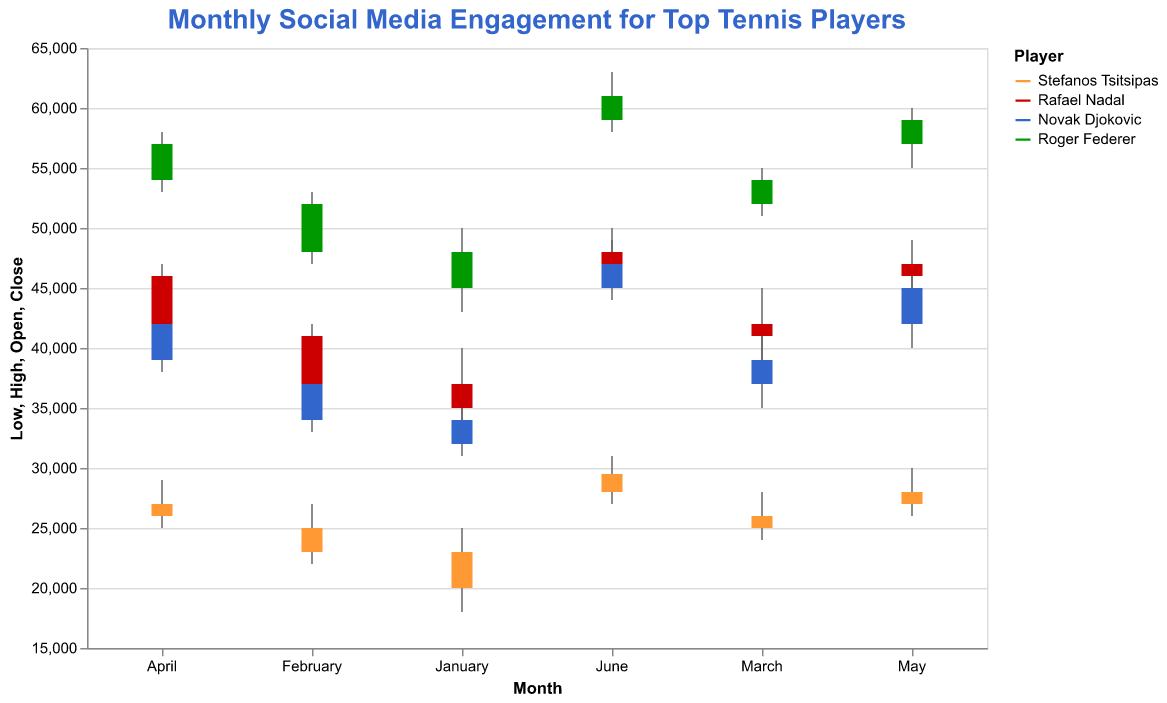What is the highest social media engagement for Stefanos Tsitsipas in February? The highest social media engagement for Stefanos Tsitsipas in February is displayed as the "High" value for that month. According to the data, this value is 27000.
Answer: 27000 How much did Rafael Nadal's social media engagement increase from January to February? To find the increase, subtract Nadal's "Open" engagement in January from his "Close" engagement in February. The values are 37000 (February Close) and 35000 (January Open). The increase is 37000 - 35000 = 2000.
Answer: 2000 Which player had the lowest social media engagement in March? To find this, look at the "Low" values for each player in March. Tsitsipas has 24000, Nadal has 39000, Djokovic has 35000, and Federer has 51000. The lowest value is 24000 for Tsitsipas.
Answer: Stefanos Tsitsipas Compare the social media engagement in June for Stefanos Tsitsipas and Rafael Nadal. Who had higher "Close" engagement? Compare the "Close" values in June for both players. Tsitsipas has 29500 and Nadal has 48000. Nadal's engagement is higher.
Answer: Rafael Nadal What is the range of social media engagement for Novak Djokovic in April? The range is found by subtracting the "Low" value from the "High" value for April. For Djokovic, these values are 38000 (Low) and 43000 (High). The range is 43000 - 38000 = 5000.
Answer: 5000 Which month shows the highest closing engagement for Roger Federer? To find this, examine the "Close" values for Federer across all months. The values are January (48000), February (52000), March (54000), April (57000), May (59000), and June (61000). The highest is 61000 in June.
Answer: June What is the average "Close" engagement for Stefanos Tsitsipas from January to June? To calculate the average "Close" engagement, sum the "Close" values for Tsitsipas from January to June and divide by the number of months. The sum is  (23000 + 25000 + 26000 + 27000 + 28000 + 29500) = 158500. The average is 158500 / 6 ≈ 26417.
Answer: 26417 How does the "Open" engagement for Rafael Nadal in May compare to the "Close" engagement for Novak Djokovic in the same month? Compare the "Open" value for Nadal and the "Close" value for Djokovic in May. Nadal's "Open" is 46000 while Djokovic's "Close" is 45000. Nadal's engagement is higher.
Answer: Rafael Nadal Which player showed the greatest increase in social media engagement from January to June? Calculate the difference between January's "Open" and June's "Close" values for each player. Tsitsipas: 29500 - 20000 = 9500, Nadal: 48000 - 35000 = 13000, Djokovic: 47000 - 32000 = 15000, Federer: 61000 - 45000 = 16000. Federer shows the greatest increase.
Answer: Roger Federer 